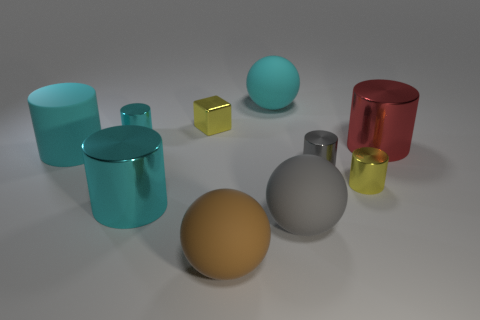Can the arrangement of objects tell us something about the concept being conveyed? The arrangement of objects doesn't appear to follow any specific pattern and seems random. This randomness could suggest a theme of diversity or a study in contrasts—showcasing how different shapes, sizes, and materials can coexist within the same space without a particular order. Could you consider any of these objects as the visual focus of this image? The golden sphere near the center seems to be the focal point because of its central positioning and its distinct color, which draws the eye amidst the otherwise cooler palette of the surrounding objects. 